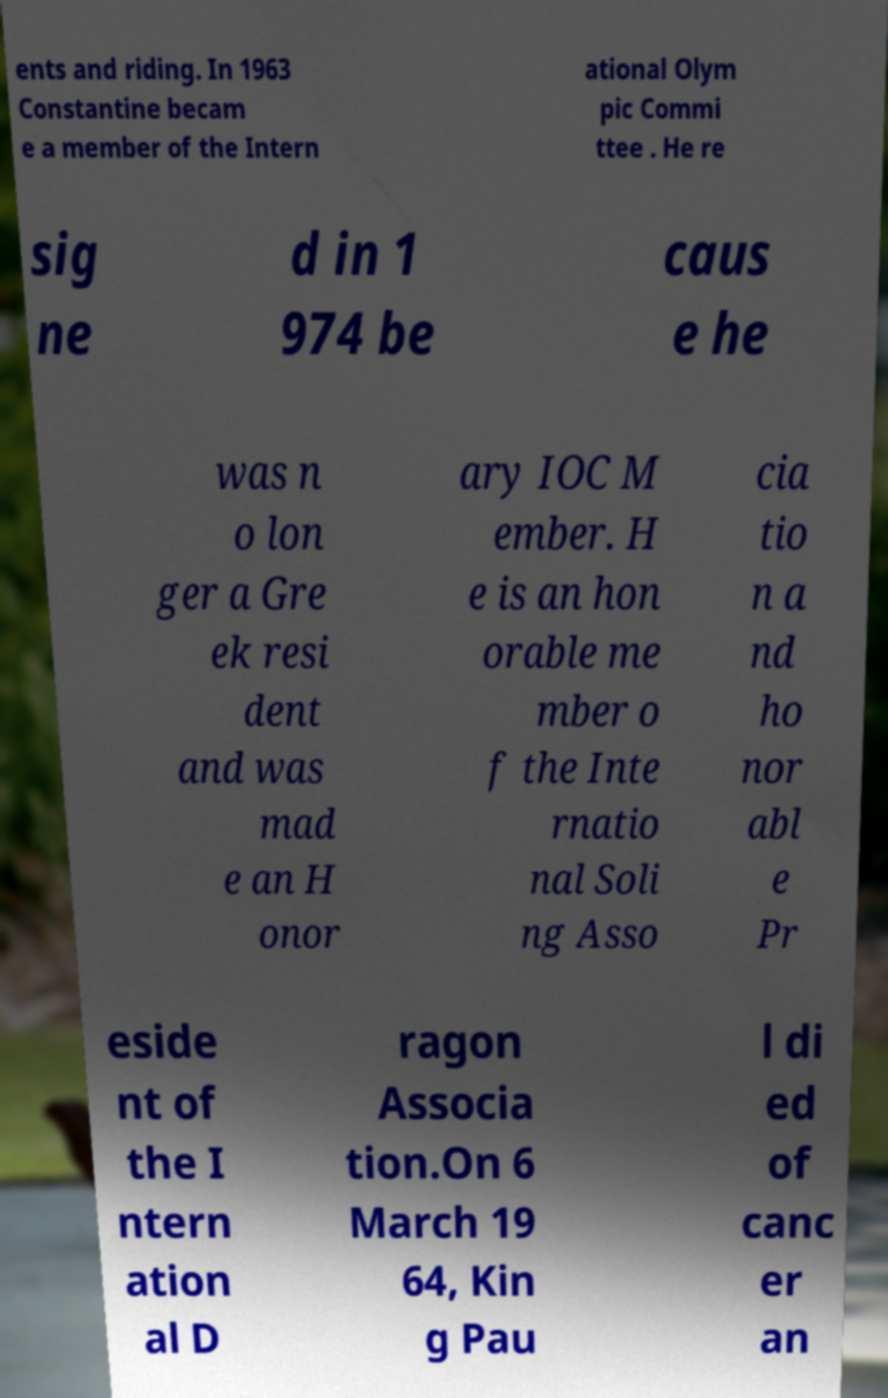For documentation purposes, I need the text within this image transcribed. Could you provide that? ents and riding. In 1963 Constantine becam e a member of the Intern ational Olym pic Commi ttee . He re sig ne d in 1 974 be caus e he was n o lon ger a Gre ek resi dent and was mad e an H onor ary IOC M ember. H e is an hon orable me mber o f the Inte rnatio nal Soli ng Asso cia tio n a nd ho nor abl e Pr eside nt of the I ntern ation al D ragon Associa tion.On 6 March 19 64, Kin g Pau l di ed of canc er an 